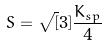Convert formula to latex. <formula><loc_0><loc_0><loc_500><loc_500>S = \sqrt { [ } 3 ] { \frac { K _ { s p } } { 4 } }</formula> 